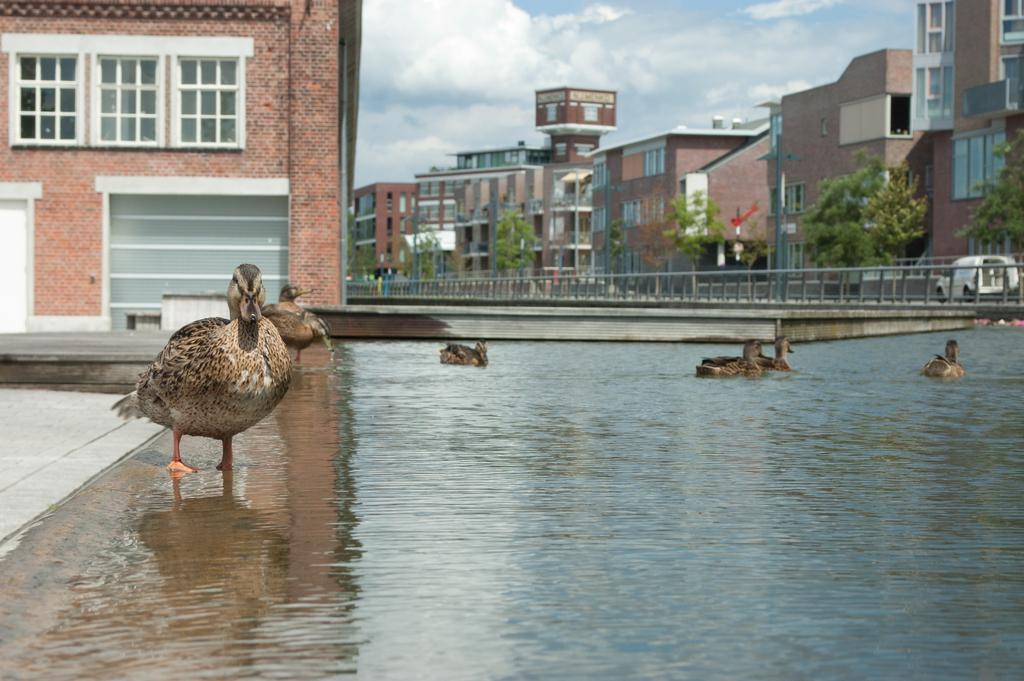What is located in the center of the image? There are birds in the water in the center of the image. What can be seen in the background of the image? The sky, clouds, buildings, windows, poles, trees, and a fence are visible in the background of the image. Can you describe the sky in the background? The sky is visible in the background of the image. How many vehicles are visible in the background of the image? One vehicle is visible in the background of the image. Reasoning: Let' Let's think step by step in order to produce the conversation. We start by identifying the main subject in the image, which is the birds in the water. Then, we expand the conversation to include the various elements visible in the background, such as the sky, clouds, buildings, windows, poles, trees, and a fence. We also mention the presence of a vehicle in the background. Each question is designed to elicit a specific detail about the image that is known from the provided facts. Absurd Question/Answer: How many women are present in the image, and what are they doing? There is no mention of women in the image, so we cannot answer this question. What type of mailbox can be seen in the image? There is no mailbox present in the image. 